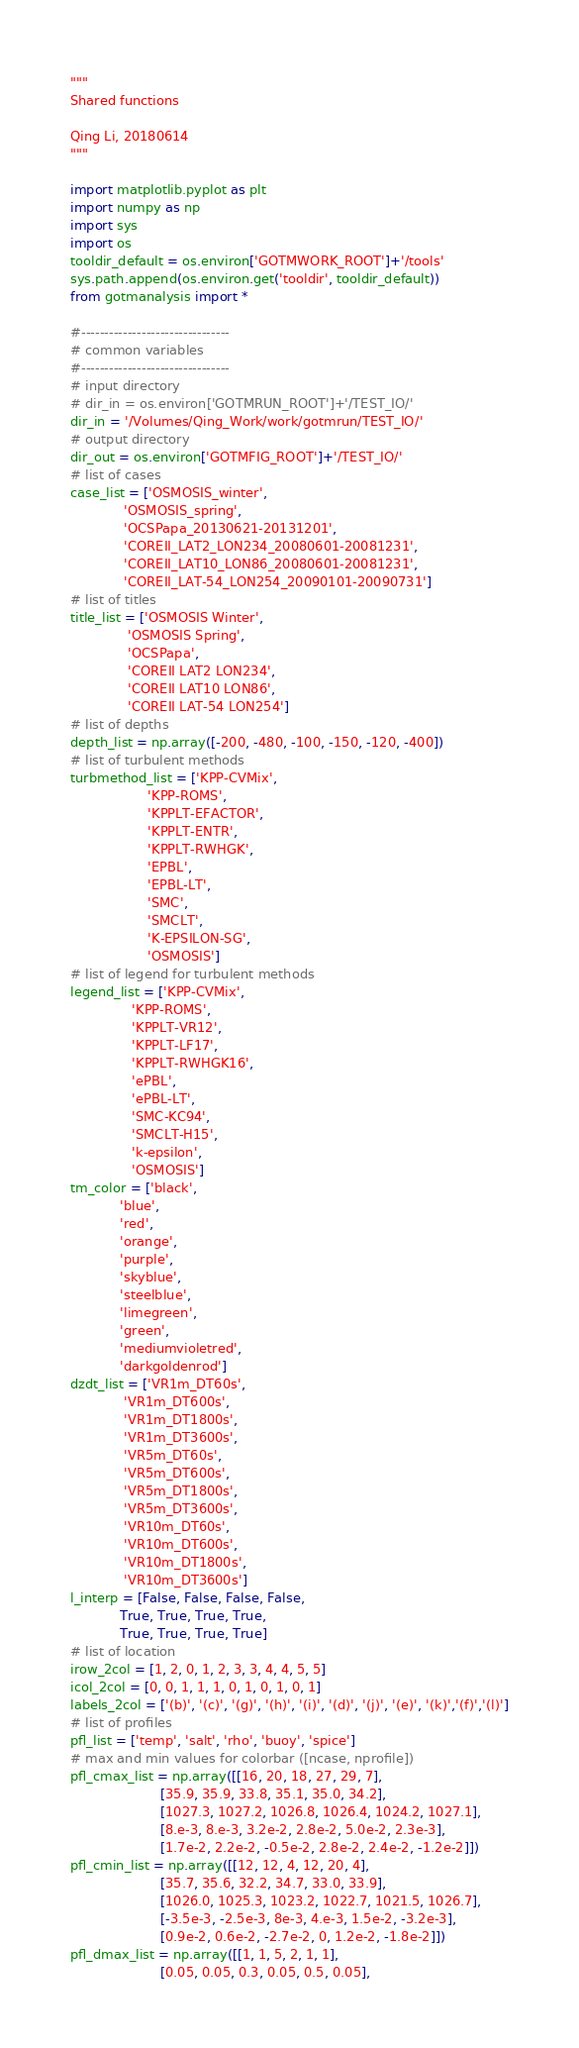<code> <loc_0><loc_0><loc_500><loc_500><_Python_>"""
Shared functions

Qing Li, 20180614
"""

import matplotlib.pyplot as plt
import numpy as np
import sys
import os
tooldir_default = os.environ['GOTMWORK_ROOT']+'/tools'
sys.path.append(os.environ.get('tooldir', tooldir_default))
from gotmanalysis import *

#--------------------------------
# common variables
#--------------------------------
# input directory
# dir_in = os.environ['GOTMRUN_ROOT']+'/TEST_IO/'
dir_in = '/Volumes/Qing_Work/work/gotmrun/TEST_IO/'
# output directory
dir_out = os.environ['GOTMFIG_ROOT']+'/TEST_IO/'
# list of cases
case_list = ['OSMOSIS_winter',
             'OSMOSIS_spring',
             'OCSPapa_20130621-20131201',
             'COREII_LAT2_LON234_20080601-20081231',
             'COREII_LAT10_LON86_20080601-20081231',
             'COREII_LAT-54_LON254_20090101-20090731']
# list of titles
title_list = ['OSMOSIS Winter',
              'OSMOSIS Spring',
              'OCSPapa',
              'COREII LAT2 LON234',
              'COREII LAT10 LON86',
              'COREII LAT-54 LON254']
# list of depths
depth_list = np.array([-200, -480, -100, -150, -120, -400])
# list of turbulent methods
turbmethod_list = ['KPP-CVMix',
                   'KPP-ROMS',
                   'KPPLT-EFACTOR',
                   'KPPLT-ENTR',
                   'KPPLT-RWHGK',
                   'EPBL',
                   'EPBL-LT',
                   'SMC',
                   'SMCLT',
                   'K-EPSILON-SG',
                   'OSMOSIS']
# list of legend for turbulent methods
legend_list = ['KPP-CVMix',
               'KPP-ROMS',
               'KPPLT-VR12',
               'KPPLT-LF17',
               'KPPLT-RWHGK16',
               'ePBL',
               'ePBL-LT',
               'SMC-KC94',
               'SMCLT-H15',
               'k-epsilon',
               'OSMOSIS']
tm_color = ['black',
            'blue',
            'red',
            'orange',
            'purple',
            'skyblue',
            'steelblue',
            'limegreen',
            'green',
            'mediumvioletred',
            'darkgoldenrod']
dzdt_list = ['VR1m_DT60s',
             'VR1m_DT600s',
             'VR1m_DT1800s',
             'VR1m_DT3600s',
             'VR5m_DT60s',
             'VR5m_DT600s',
             'VR5m_DT1800s',
             'VR5m_DT3600s',
             'VR10m_DT60s',
             'VR10m_DT600s',
             'VR10m_DT1800s',
             'VR10m_DT3600s']
l_interp = [False, False, False, False,
            True, True, True, True,
            True, True, True, True]
# list of location
irow_2col = [1, 2, 0, 1, 2, 3, 3, 4, 4, 5, 5]
icol_2col = [0, 0, 1, 1, 1, 0, 1, 0, 1, 0, 1]
labels_2col = ['(b)', '(c)', '(g)', '(h)', '(i)', '(d)', '(j)', '(e)', '(k)','(f)','(l)']
# list of profiles
pfl_list = ['temp', 'salt', 'rho', 'buoy', 'spice']
# max and min values for colorbar ([ncase, nprofile])
pfl_cmax_list = np.array([[16, 20, 18, 27, 29, 7],
                      [35.9, 35.9, 33.8, 35.1, 35.0, 34.2],
                      [1027.3, 1027.2, 1026.8, 1026.4, 1024.2, 1027.1],
                      [8.e-3, 8.e-3, 3.2e-2, 2.8e-2, 5.0e-2, 2.3e-3],
                      [1.7e-2, 2.2e-2, -0.5e-2, 2.8e-2, 2.4e-2, -1.2e-2]])
pfl_cmin_list = np.array([[12, 12, 4, 12, 20, 4],
                      [35.7, 35.6, 32.2, 34.7, 33.0, 33.9],
                      [1026.0, 1025.3, 1023.2, 1022.7, 1021.5, 1026.7],
                      [-3.5e-3, -2.5e-3, 8e-3, 4.e-3, 1.5e-2, -3.2e-3],
                      [0.9e-2, 0.6e-2, -2.7e-2, 0, 1.2e-2, -1.8e-2]])
pfl_dmax_list = np.array([[1, 1, 5, 2, 1, 1],
                      [0.05, 0.05, 0.3, 0.05, 0.5, 0.05],</code> 